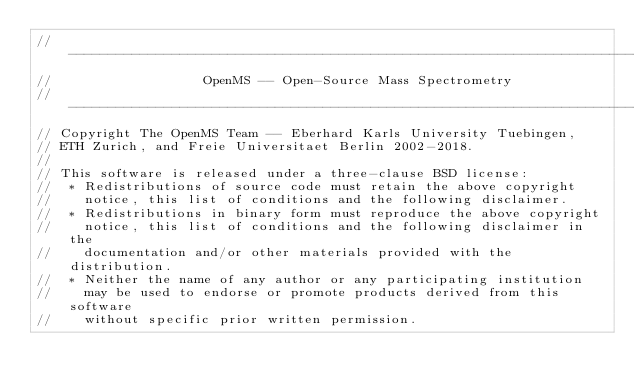Convert code to text. <code><loc_0><loc_0><loc_500><loc_500><_C++_>// --------------------------------------------------------------------------
//                   OpenMS -- Open-Source Mass Spectrometry
// --------------------------------------------------------------------------
// Copyright The OpenMS Team -- Eberhard Karls University Tuebingen,
// ETH Zurich, and Freie Universitaet Berlin 2002-2018.
//
// This software is released under a three-clause BSD license:
//  * Redistributions of source code must retain the above copyright
//    notice, this list of conditions and the following disclaimer.
//  * Redistributions in binary form must reproduce the above copyright
//    notice, this list of conditions and the following disclaimer in the
//    documentation and/or other materials provided with the distribution.
//  * Neither the name of any author or any participating institution
//    may be used to endorse or promote products derived from this software
//    without specific prior written permission.</code> 